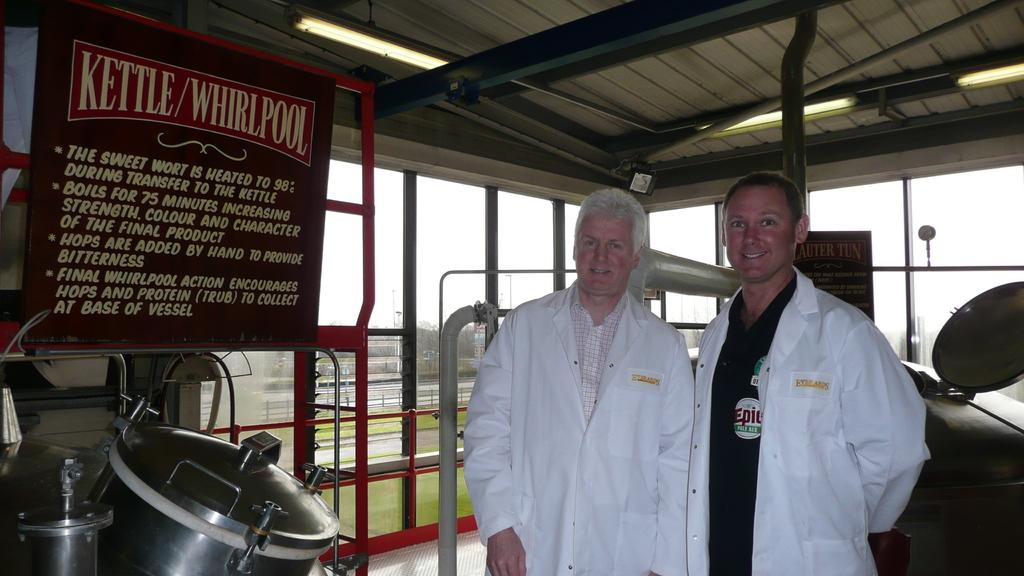<image>
Summarize the visual content of the image. Two men in front of a sign that says Kettle/Whirlpool 